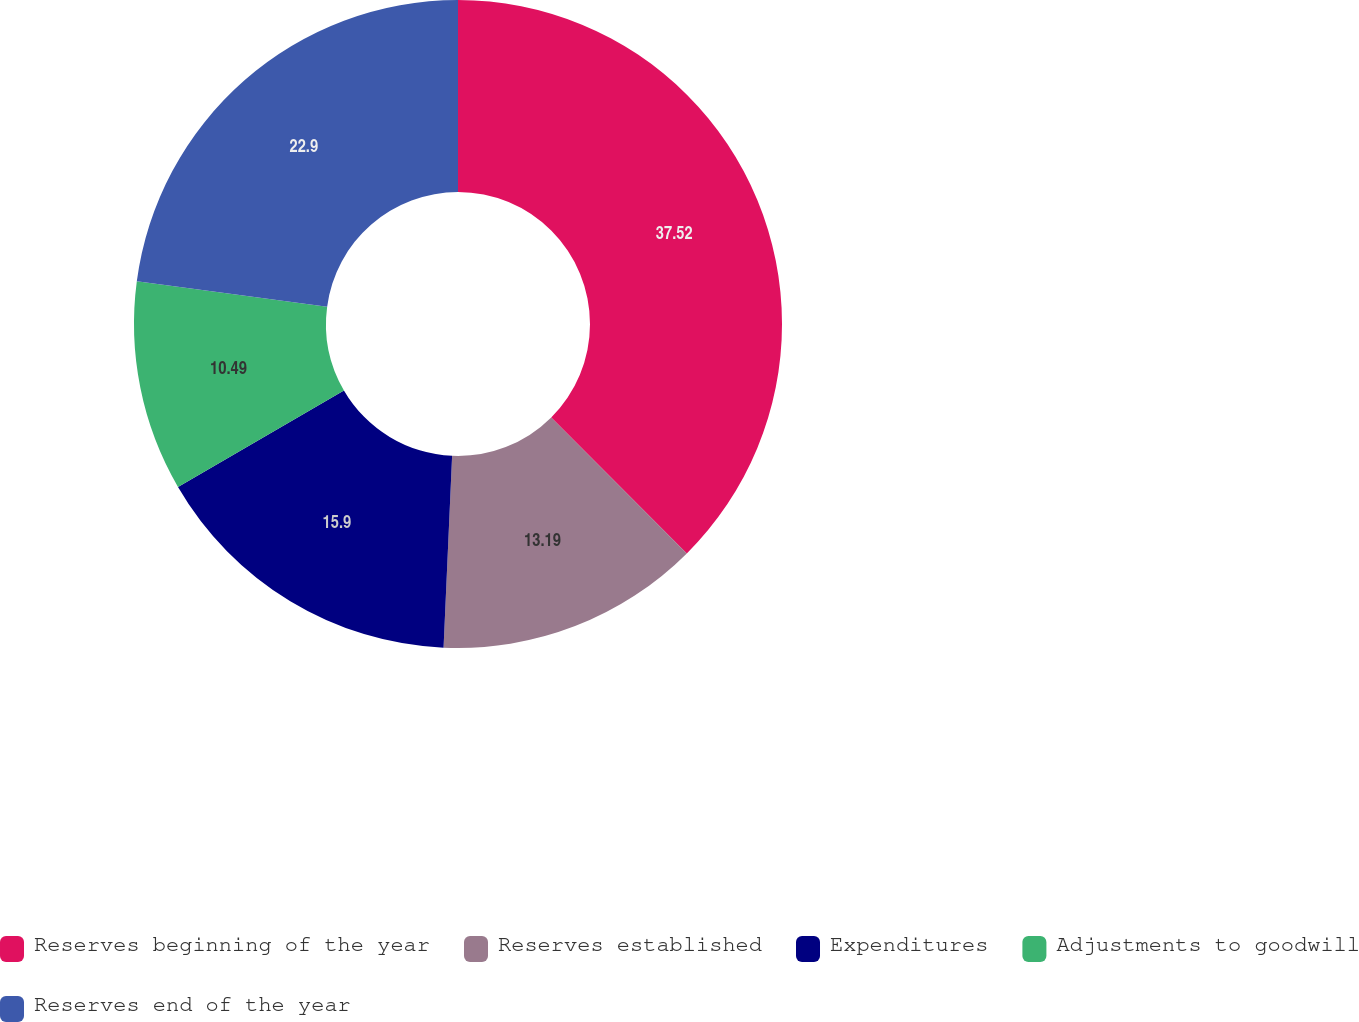Convert chart to OTSL. <chart><loc_0><loc_0><loc_500><loc_500><pie_chart><fcel>Reserves beginning of the year<fcel>Reserves established<fcel>Expenditures<fcel>Adjustments to goodwill<fcel>Reserves end of the year<nl><fcel>37.52%<fcel>13.19%<fcel>15.9%<fcel>10.49%<fcel>22.9%<nl></chart> 